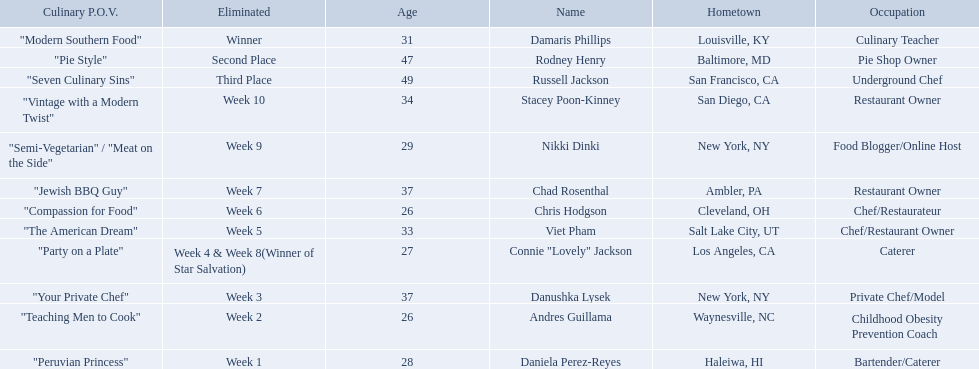Who are all of the contestants? Damaris Phillips, Rodney Henry, Russell Jackson, Stacey Poon-Kinney, Nikki Dinki, Chad Rosenthal, Chris Hodgson, Viet Pham, Connie "Lovely" Jackson, Danushka Lysek, Andres Guillama, Daniela Perez-Reyes. Which culinary p.o.v. is longer than vintage with a modern twist? "Semi-Vegetarian" / "Meat on the Side". Which contestant's p.o.v. is semi-vegetarian/meat on the side? Nikki Dinki. 